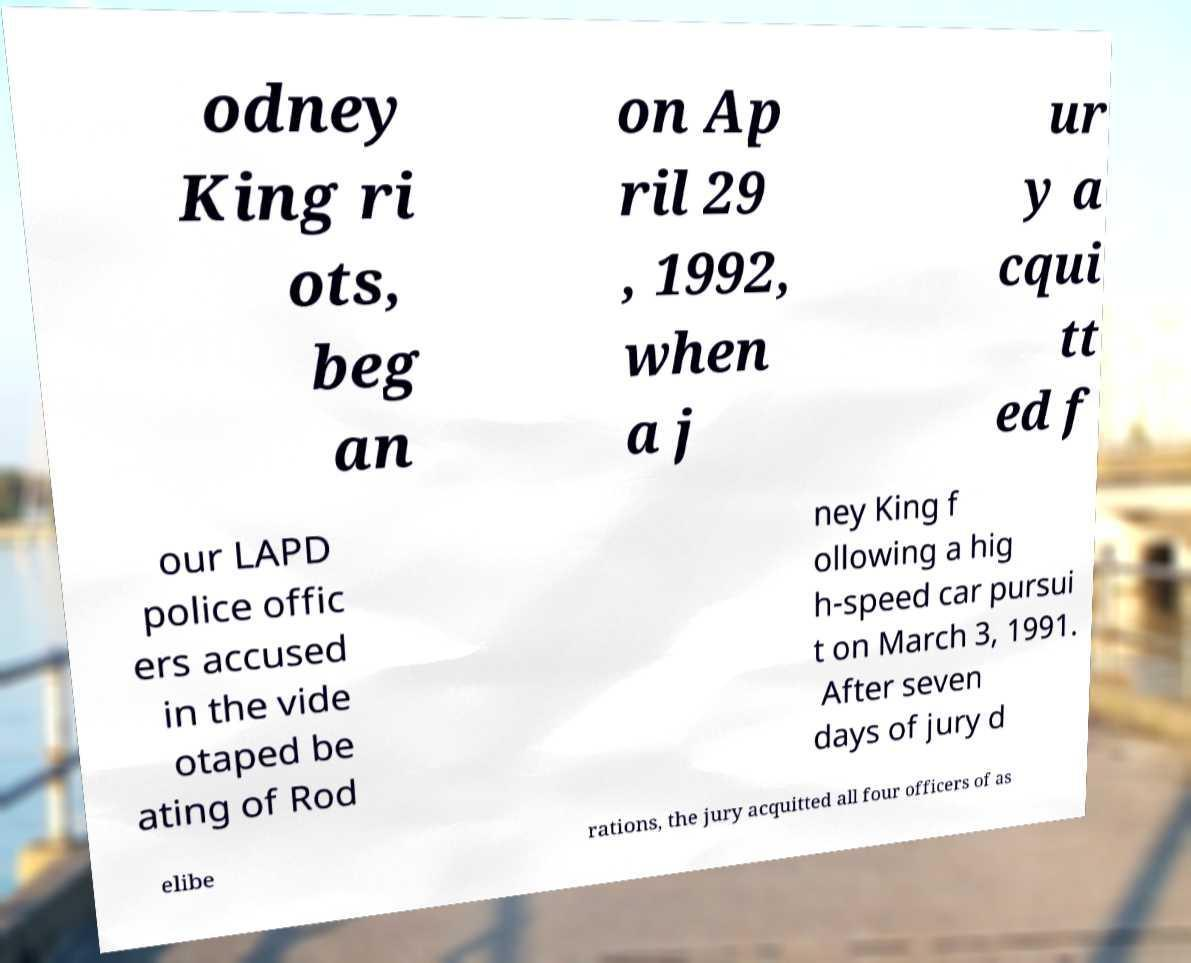I need the written content from this picture converted into text. Can you do that? odney King ri ots, beg an on Ap ril 29 , 1992, when a j ur y a cqui tt ed f our LAPD police offic ers accused in the vide otaped be ating of Rod ney King f ollowing a hig h-speed car pursui t on March 3, 1991. After seven days of jury d elibe rations, the jury acquitted all four officers of as 